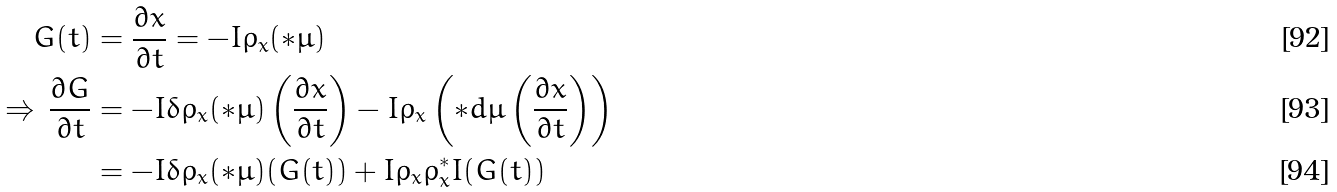Convert formula to latex. <formula><loc_0><loc_0><loc_500><loc_500>G ( t ) & = \frac { \partial x } { \partial t } = - I \rho _ { x } ( * \mu ) \\ \Rightarrow \, \frac { \partial G } { \partial t } & = - I \delta \rho _ { x } ( * \mu ) \left ( \frac { \partial x } { \partial t } \right ) - I \rho _ { x } \left ( * d \mu \left ( \frac { \partial x } { \partial t } \right ) \right ) \\ & = - I \delta \rho _ { x } ( * \mu ) ( G ( t ) ) + I \rho _ { x } \rho _ { x } ^ { * } I ( G ( t ) )</formula> 